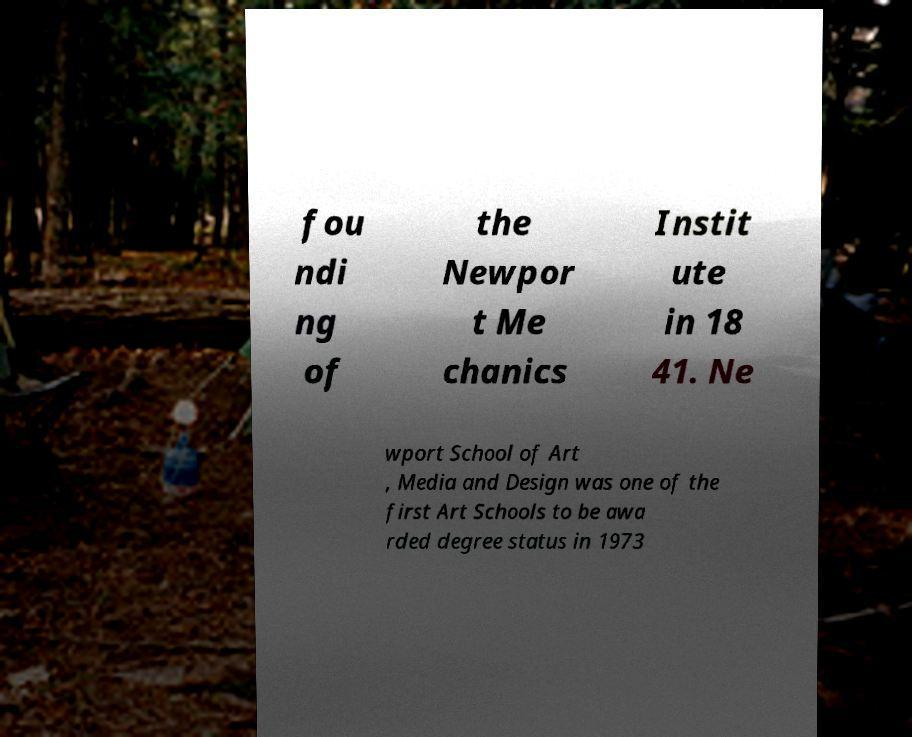I need the written content from this picture converted into text. Can you do that? fou ndi ng of the Newpor t Me chanics Instit ute in 18 41. Ne wport School of Art , Media and Design was one of the first Art Schools to be awa rded degree status in 1973 